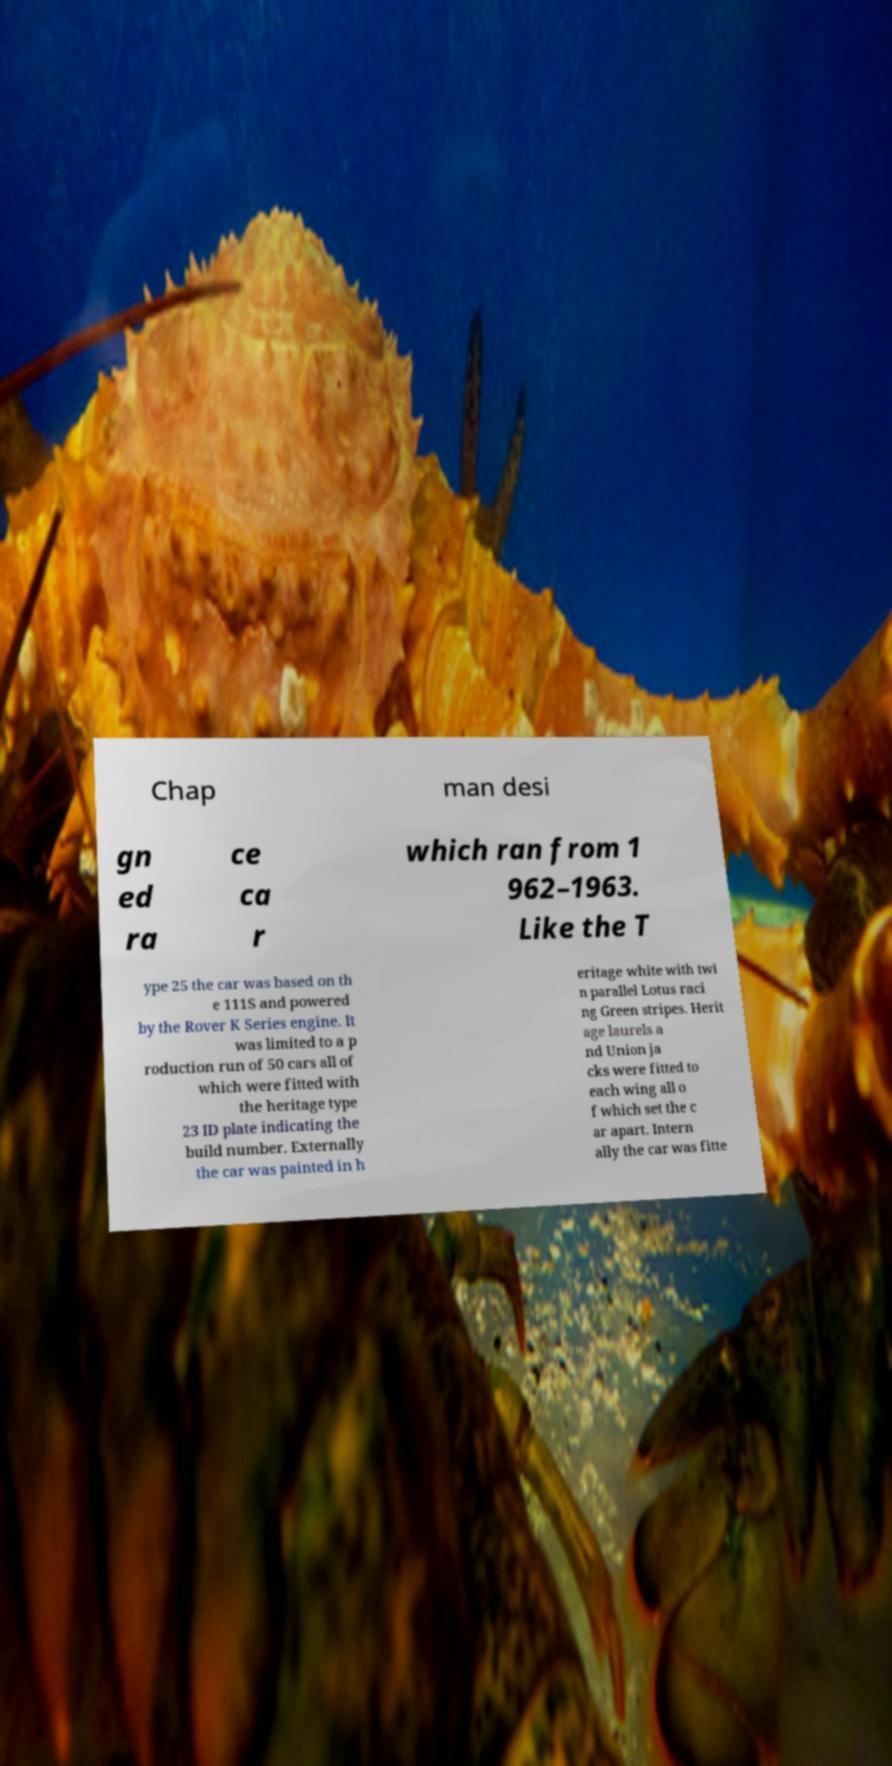Could you assist in decoding the text presented in this image and type it out clearly? Chap man desi gn ed ra ce ca r which ran from 1 962–1963. Like the T ype 25 the car was based on th e 111S and powered by the Rover K Series engine. It was limited to a p roduction run of 50 cars all of which were fitted with the heritage type 23 ID plate indicating the build number. Externally the car was painted in h eritage white with twi n parallel Lotus raci ng Green stripes. Herit age laurels a nd Union ja cks were fitted to each wing all o f which set the c ar apart. Intern ally the car was fitte 